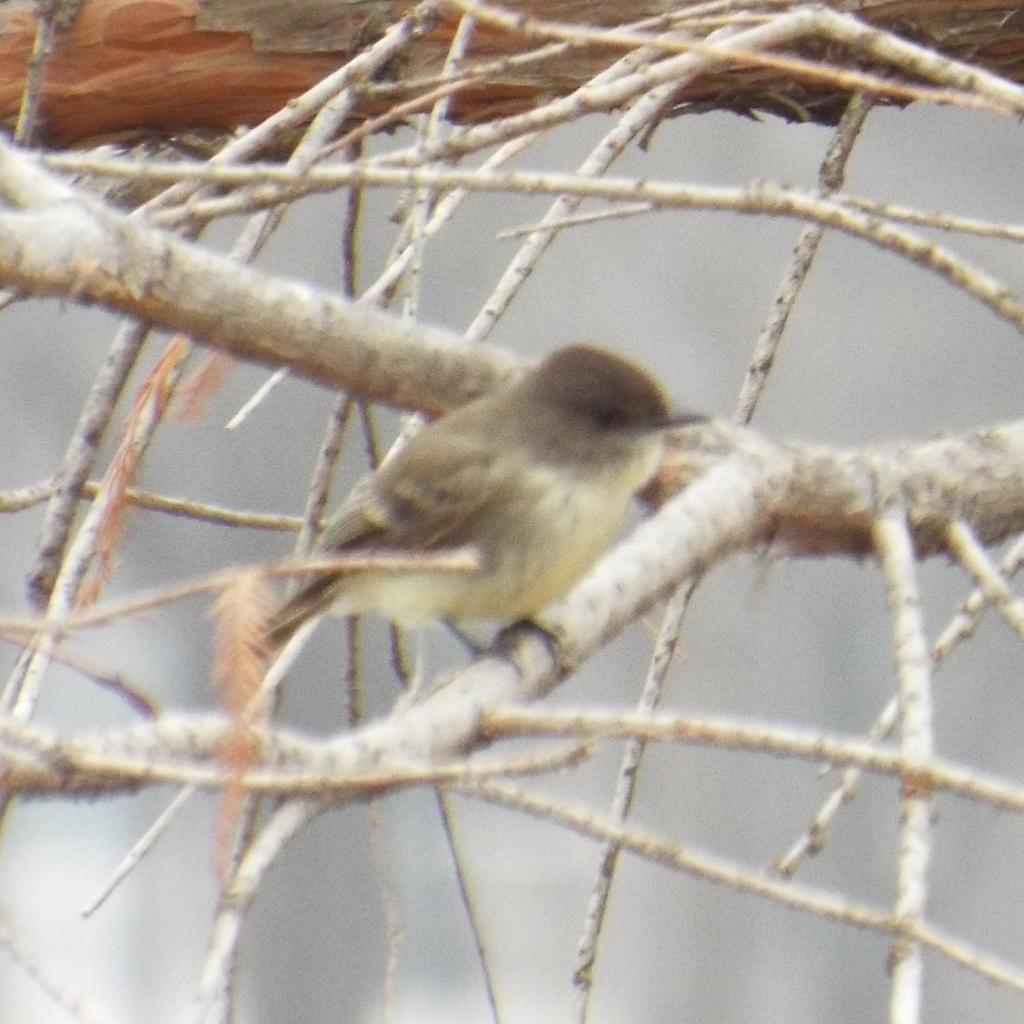What type of animal can be seen in the image? There is a bird in the image. Where is the bird located? The bird is on a branch. What else can be seen in the image besides the bird? There are stems visible in the image. Can you describe the background of the image? The background of the image is blurry. How many rabbits are sitting on the pin in the image? There are no rabbits or pins present in the image. What type of mice can be seen playing with the bird in the image? There are no mice present in the image; it features a bird on a branch. 